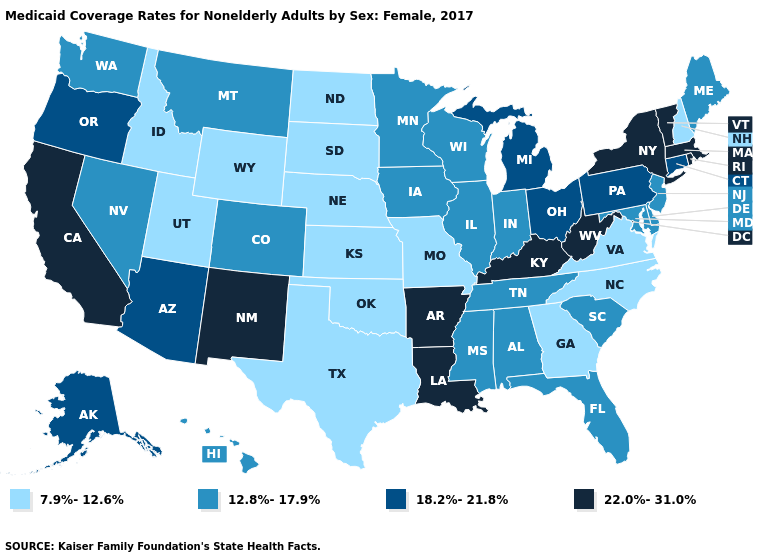Name the states that have a value in the range 18.2%-21.8%?
Write a very short answer. Alaska, Arizona, Connecticut, Michigan, Ohio, Oregon, Pennsylvania. Among the states that border Illinois , does Wisconsin have the highest value?
Concise answer only. No. Which states have the lowest value in the USA?
Keep it brief. Georgia, Idaho, Kansas, Missouri, Nebraska, New Hampshire, North Carolina, North Dakota, Oklahoma, South Dakota, Texas, Utah, Virginia, Wyoming. Which states have the highest value in the USA?
Be succinct. Arkansas, California, Kentucky, Louisiana, Massachusetts, New Mexico, New York, Rhode Island, Vermont, West Virginia. How many symbols are there in the legend?
Write a very short answer. 4. Which states have the lowest value in the West?
Keep it brief. Idaho, Utah, Wyoming. What is the value of Utah?
Keep it brief. 7.9%-12.6%. Which states hav the highest value in the Northeast?
Write a very short answer. Massachusetts, New York, Rhode Island, Vermont. What is the value of New Jersey?
Give a very brief answer. 12.8%-17.9%. Among the states that border Kansas , does Oklahoma have the lowest value?
Concise answer only. Yes. Among the states that border North Carolina , which have the lowest value?
Write a very short answer. Georgia, Virginia. Among the states that border Arizona , which have the highest value?
Be succinct. California, New Mexico. Among the states that border Virginia , which have the highest value?
Quick response, please. Kentucky, West Virginia. Does the first symbol in the legend represent the smallest category?
Give a very brief answer. Yes. Which states have the highest value in the USA?
Concise answer only. Arkansas, California, Kentucky, Louisiana, Massachusetts, New Mexico, New York, Rhode Island, Vermont, West Virginia. 